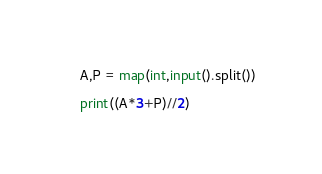Convert code to text. <code><loc_0><loc_0><loc_500><loc_500><_Python_>A,P = map(int,input().split())

print((A*3+P)//2)</code> 